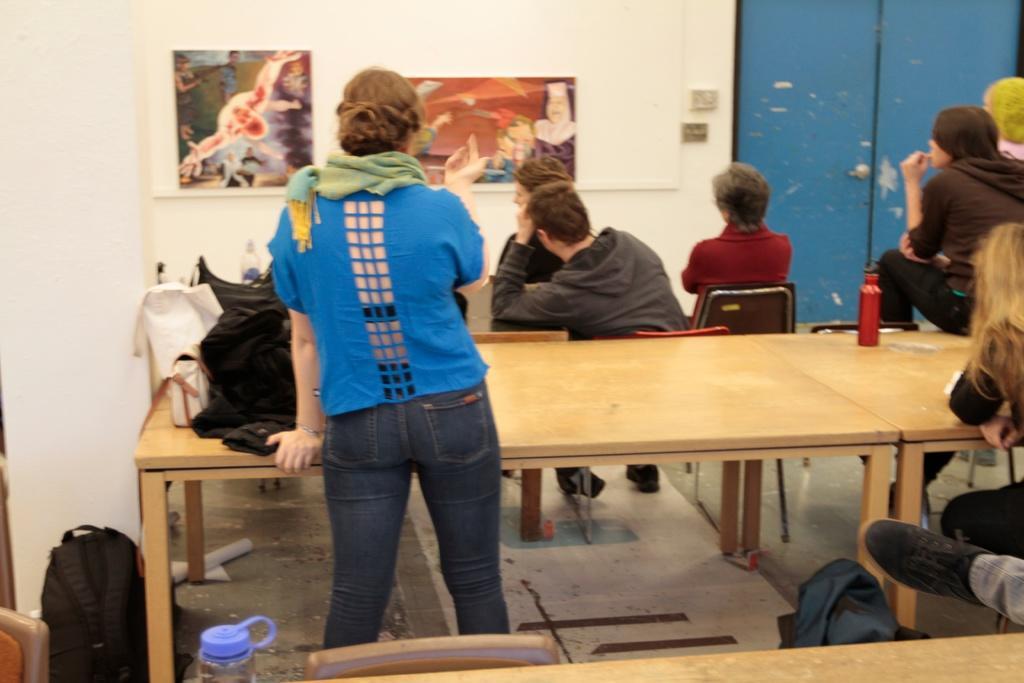Please provide a concise description of this image. In this image, there are some persons wearing colorful clothes. There is a table in front of these persons. These tables contains bottles and bags. There is a bag on the ground. These persons looking at this picture and which is attached to the wall. This person wearing a footwear. 